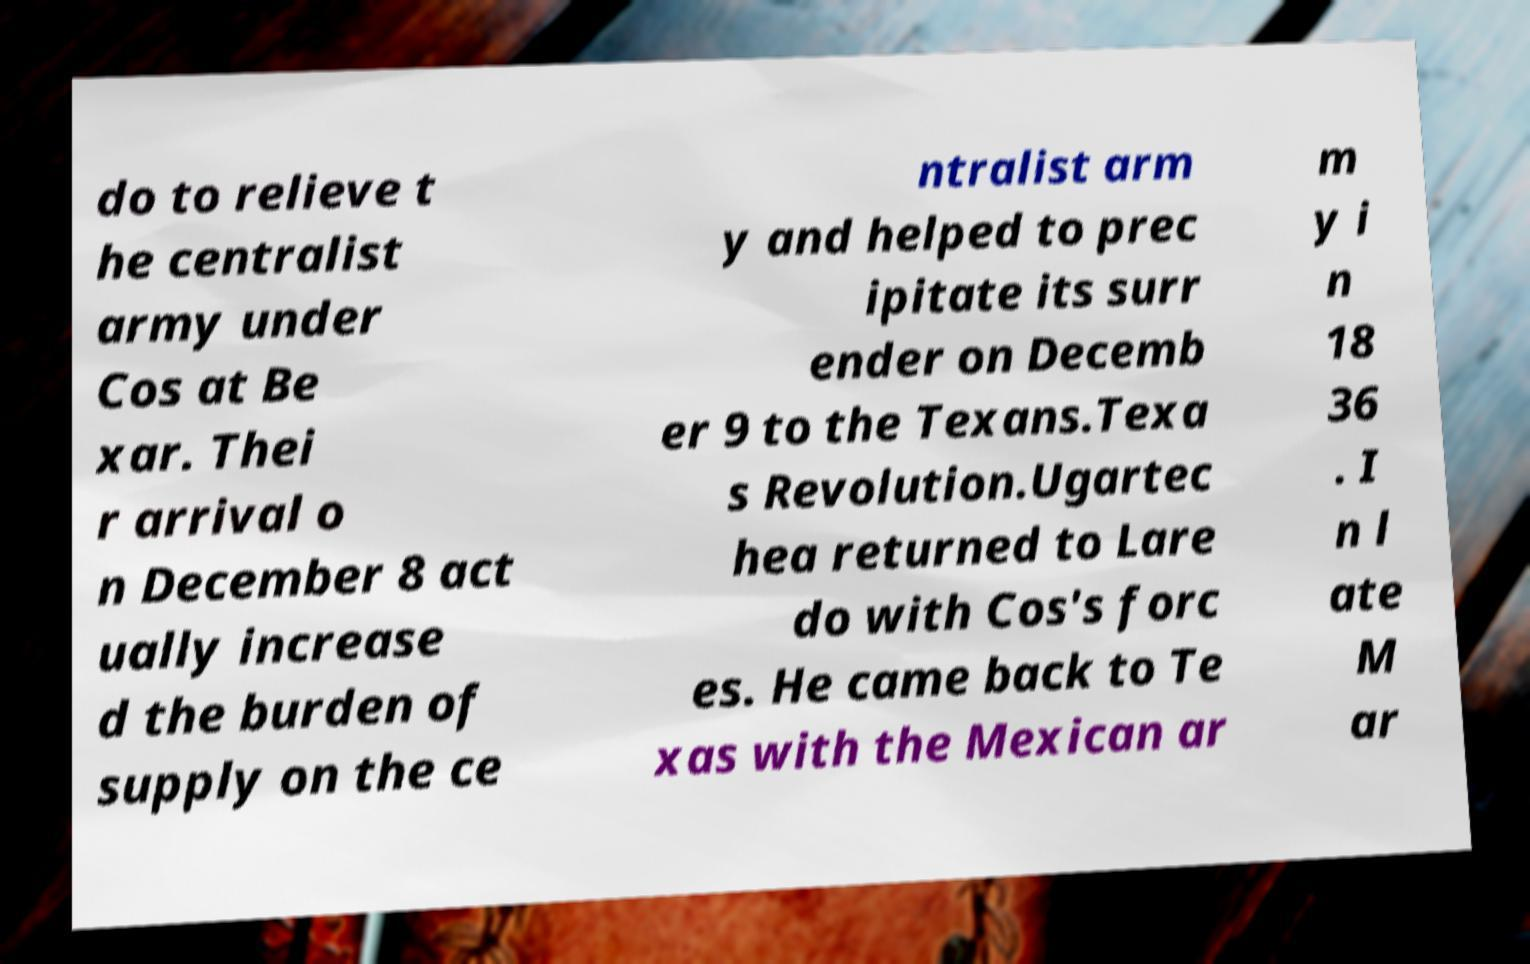I need the written content from this picture converted into text. Can you do that? do to relieve t he centralist army under Cos at Be xar. Thei r arrival o n December 8 act ually increase d the burden of supply on the ce ntralist arm y and helped to prec ipitate its surr ender on Decemb er 9 to the Texans.Texa s Revolution.Ugartec hea returned to Lare do with Cos's forc es. He came back to Te xas with the Mexican ar m y i n 18 36 . I n l ate M ar 